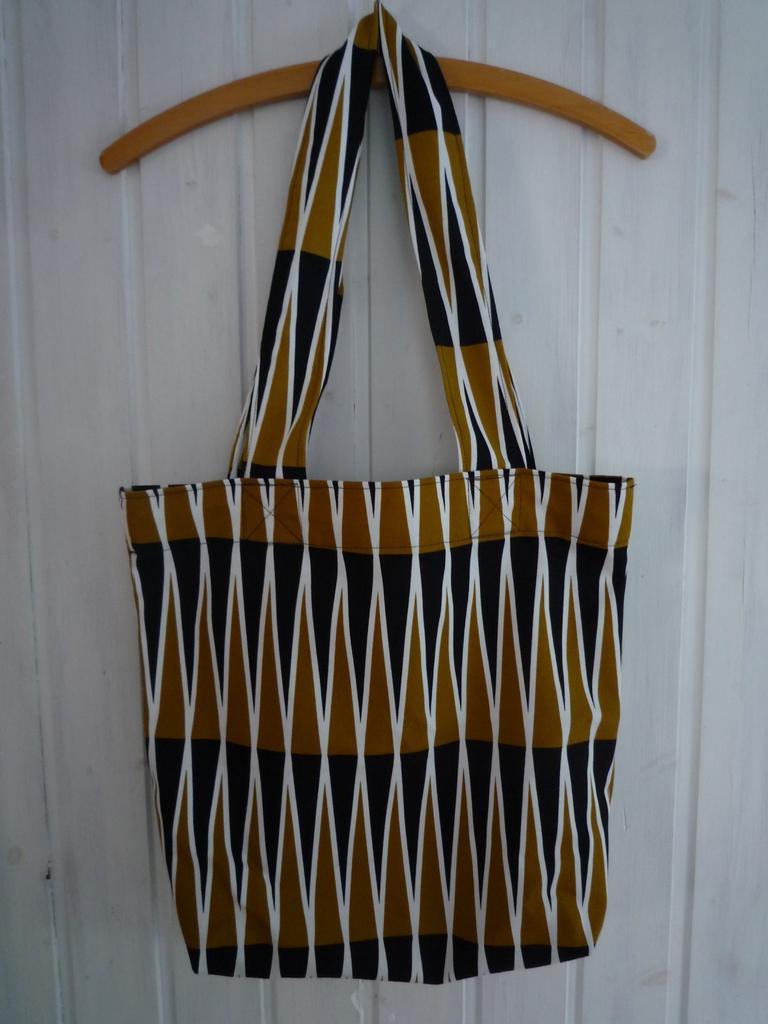Describe this image in one or two sentences. In this picture there is a bag which is hanged to the hanger. In the background there is a wall. 